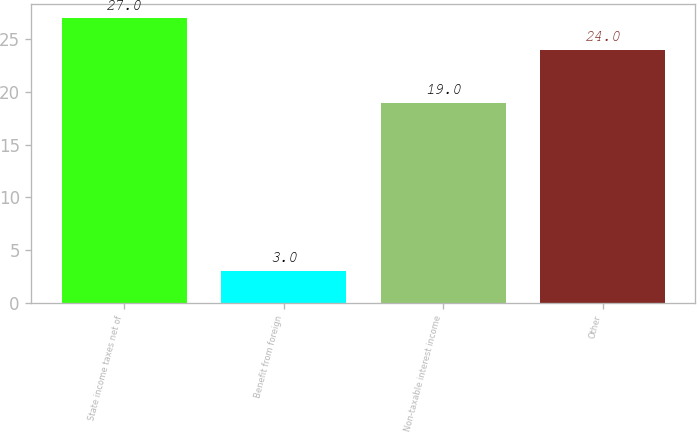Convert chart. <chart><loc_0><loc_0><loc_500><loc_500><bar_chart><fcel>State income taxes net of<fcel>Benefit from foreign<fcel>Non-taxable interest income<fcel>Other<nl><fcel>27<fcel>3<fcel>19<fcel>24<nl></chart> 